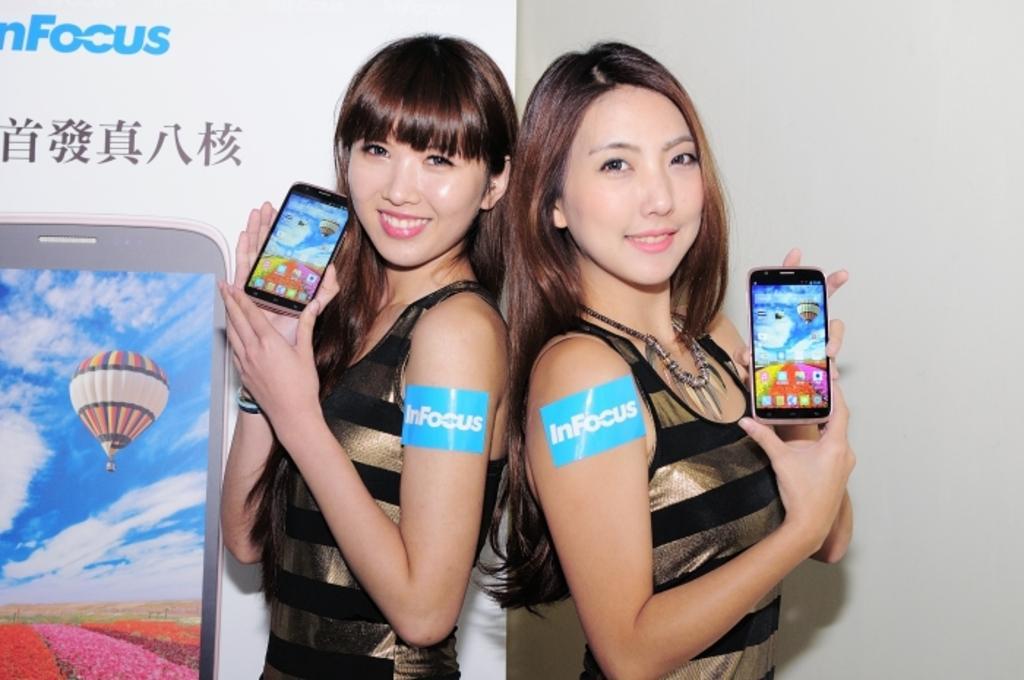Could you give a brief overview of what you see in this image? In this image, In the middle there are two girls standing and they are holding the mobile phones which are in black color, In the background there is a white color wall and there is a mobile poster which is in white color. 